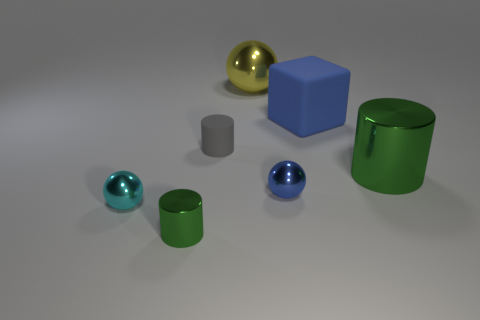Subtract all brown balls. Subtract all brown cylinders. How many balls are left? 3 Add 3 blue matte things. How many objects exist? 10 Subtract all cylinders. How many objects are left? 4 Subtract all cyan shiny balls. Subtract all small things. How many objects are left? 2 Add 6 big metallic things. How many big metallic things are left? 8 Add 6 small matte cylinders. How many small matte cylinders exist? 7 Subtract 0 brown cylinders. How many objects are left? 7 